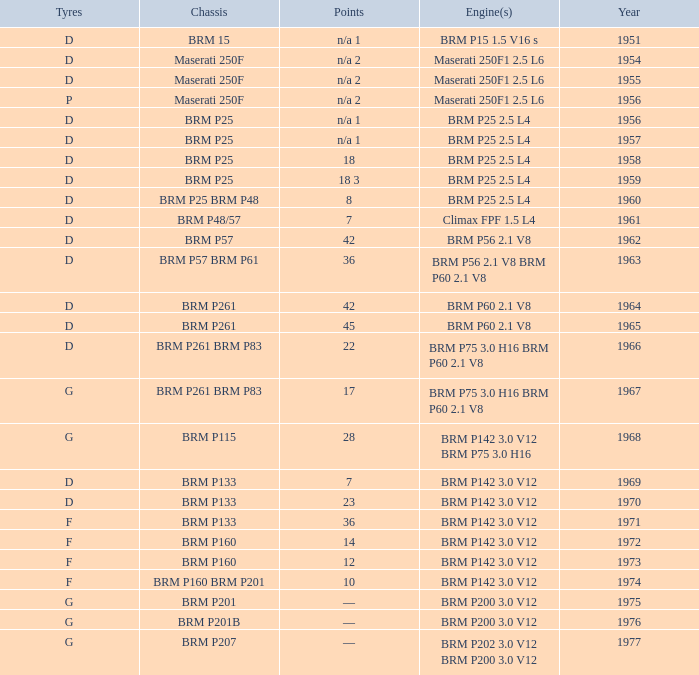Name the point for 1974 10.0. 